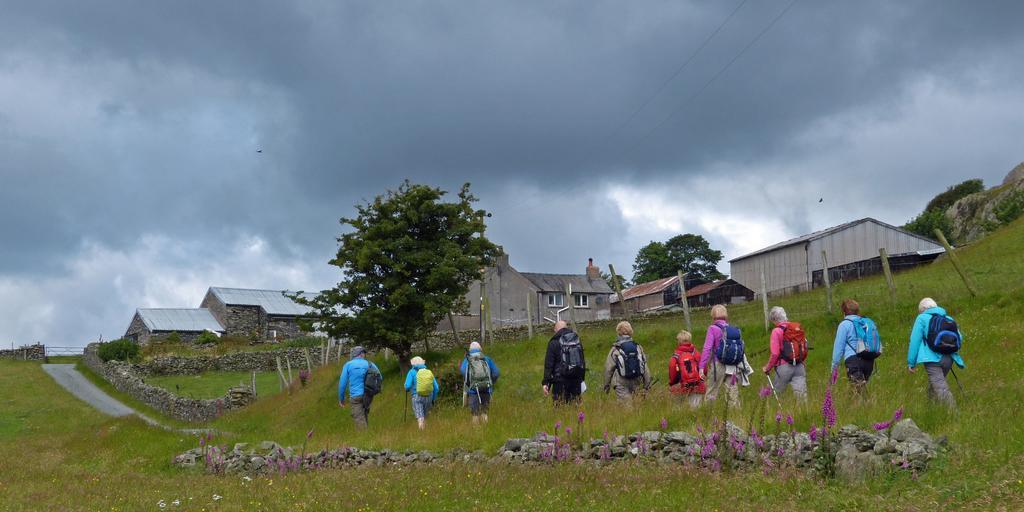Could you give a brief overview of what you see in this image? This picture is taken outside. At the bottom, there are people walking towards the left and all of them are carrying bags. At the bottom there is grass and stones. In the center, there are houses and trees. Towards the left, there is a road. On the top, there is a sky with clouds. 